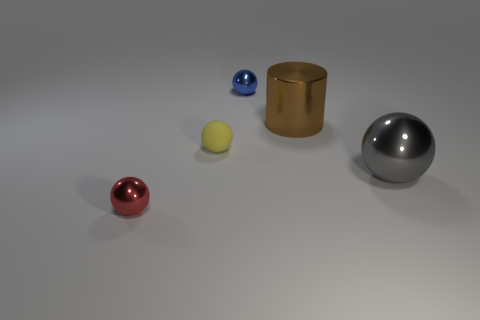Add 2 red balls. How many objects exist? 7 Subtract all large balls. How many balls are left? 3 Subtract all spheres. How many objects are left? 1 Subtract all gray spheres. How many spheres are left? 3 Subtract 0 green balls. How many objects are left? 5 Subtract 1 balls. How many balls are left? 3 Subtract all yellow balls. Subtract all red blocks. How many balls are left? 3 Subtract all matte balls. Subtract all small rubber spheres. How many objects are left? 3 Add 5 shiny objects. How many shiny objects are left? 9 Add 4 spheres. How many spheres exist? 8 